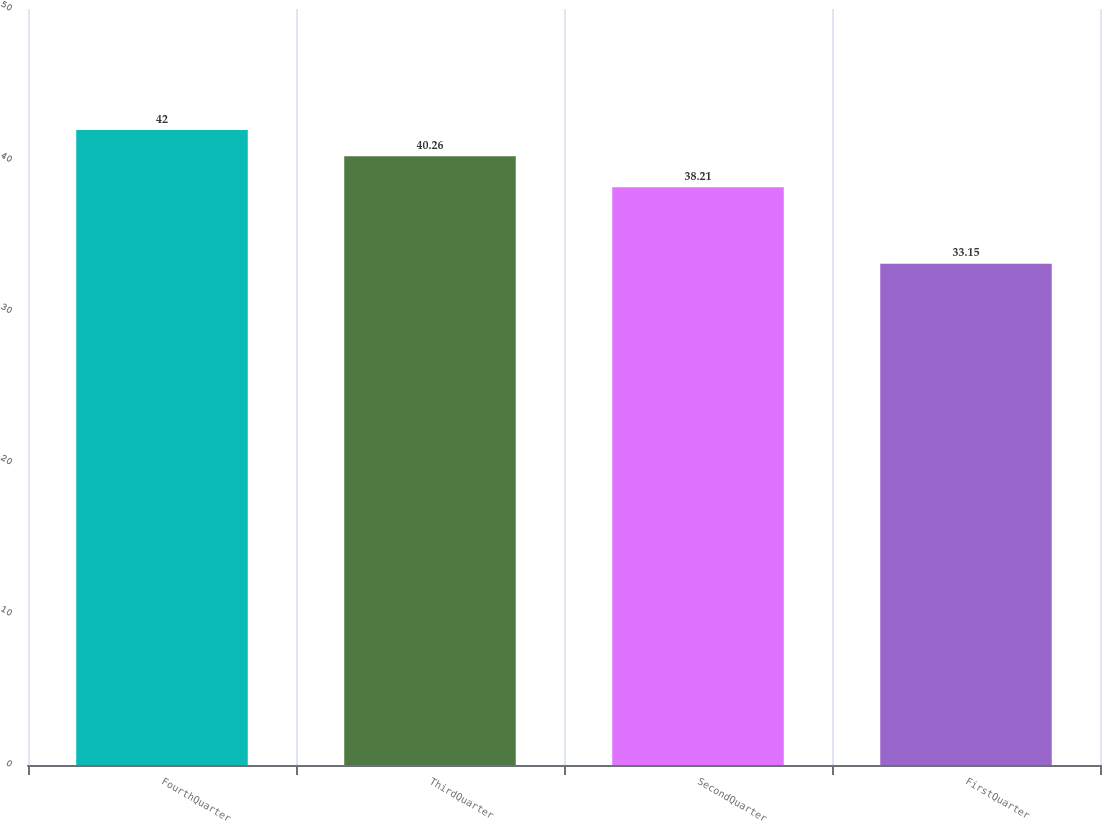<chart> <loc_0><loc_0><loc_500><loc_500><bar_chart><fcel>FourthQuarter<fcel>ThirdQuarter<fcel>SecondQuarter<fcel>FirstQuarter<nl><fcel>42<fcel>40.26<fcel>38.21<fcel>33.15<nl></chart> 